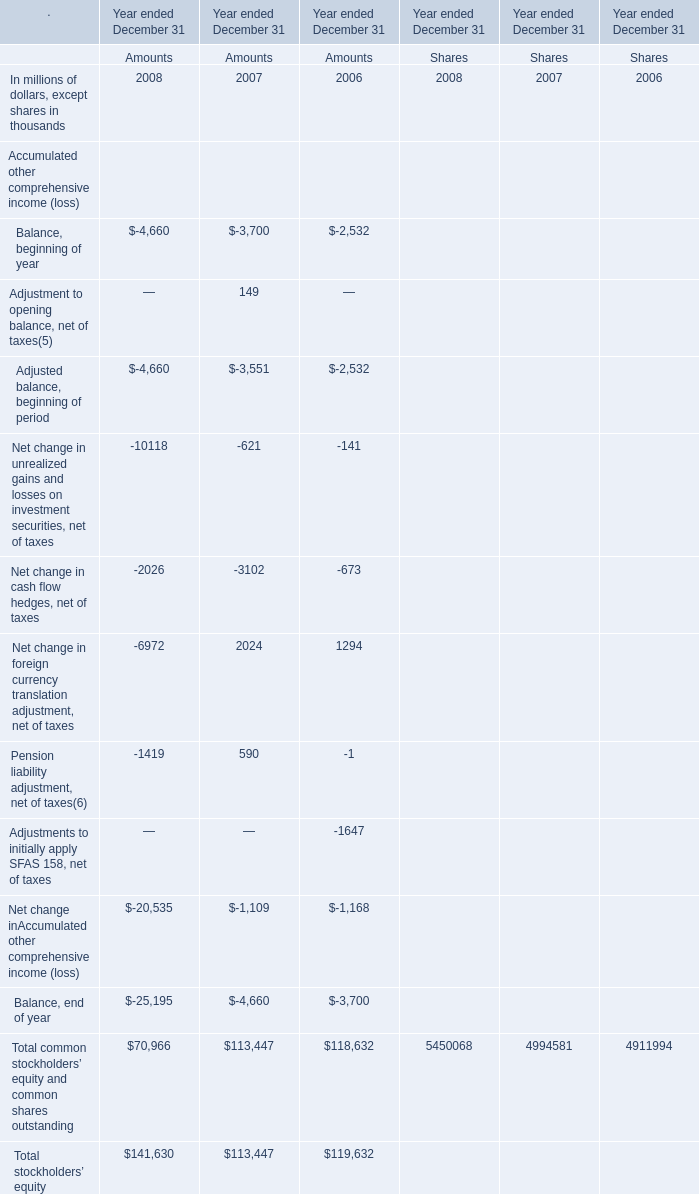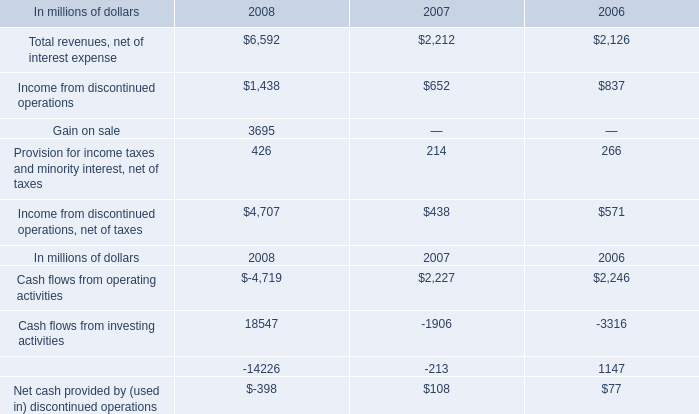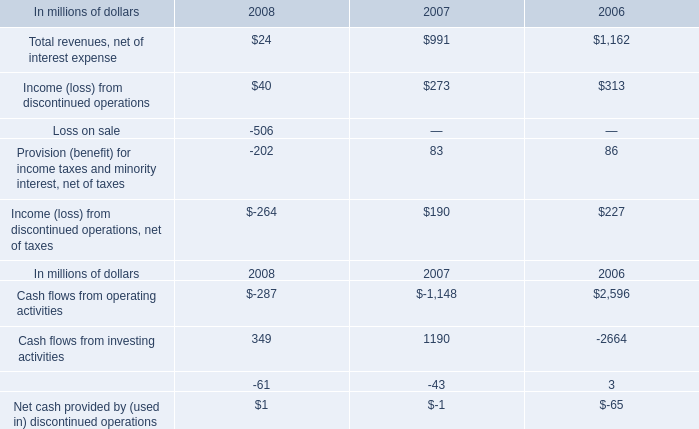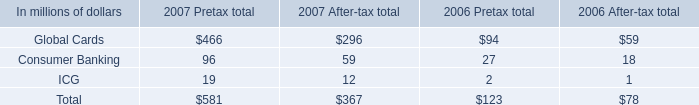What's the sum of Cash flows from operating activities of 2007, and Cash flows from investing activities of 2007 ? 
Computations: (1148.0 + 1906.0)
Answer: 3054.0. What is the sum of elements for Amounts in the range of 70000 and 150000 in 2008? (in million) 
Computations: (70966 + 141630)
Answer: 212596.0. 